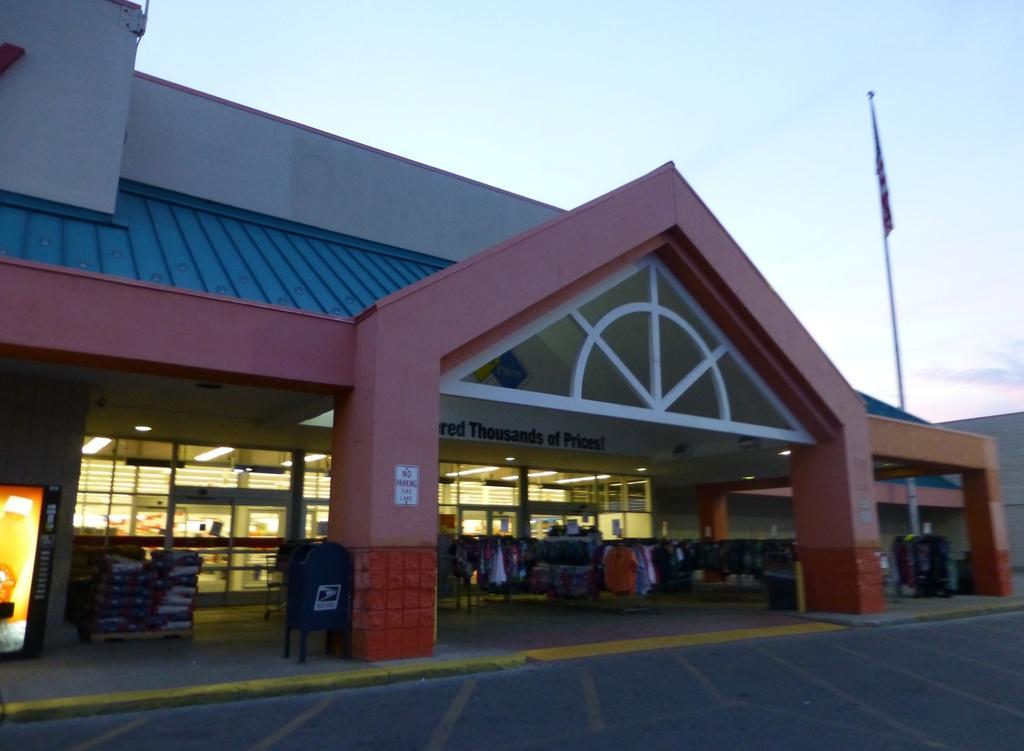Can you describe this image briefly? As we can see in the image there is a house, clothes and screen. Here there is a flag. On the top there is a sky. 